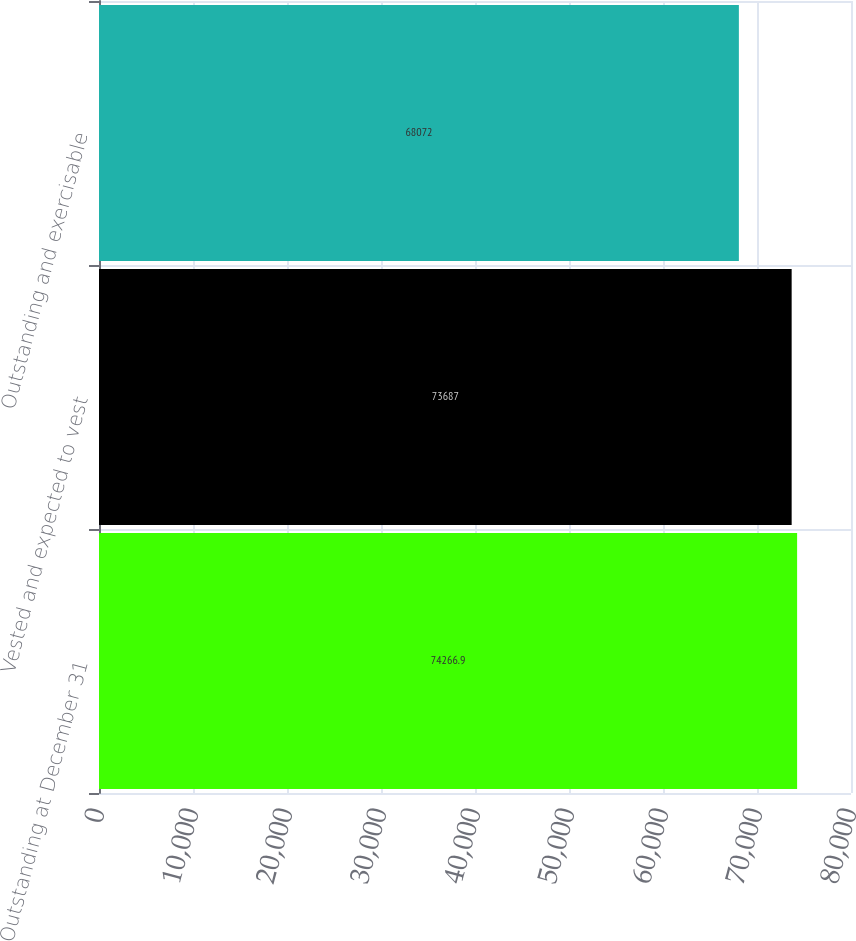<chart> <loc_0><loc_0><loc_500><loc_500><bar_chart><fcel>Outstanding at December 31<fcel>Vested and expected to vest<fcel>Outstanding and exercisable<nl><fcel>74266.9<fcel>73687<fcel>68072<nl></chart> 